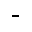Convert formula to latex. <formula><loc_0><loc_0><loc_500><loc_500>^ { - }</formula> 